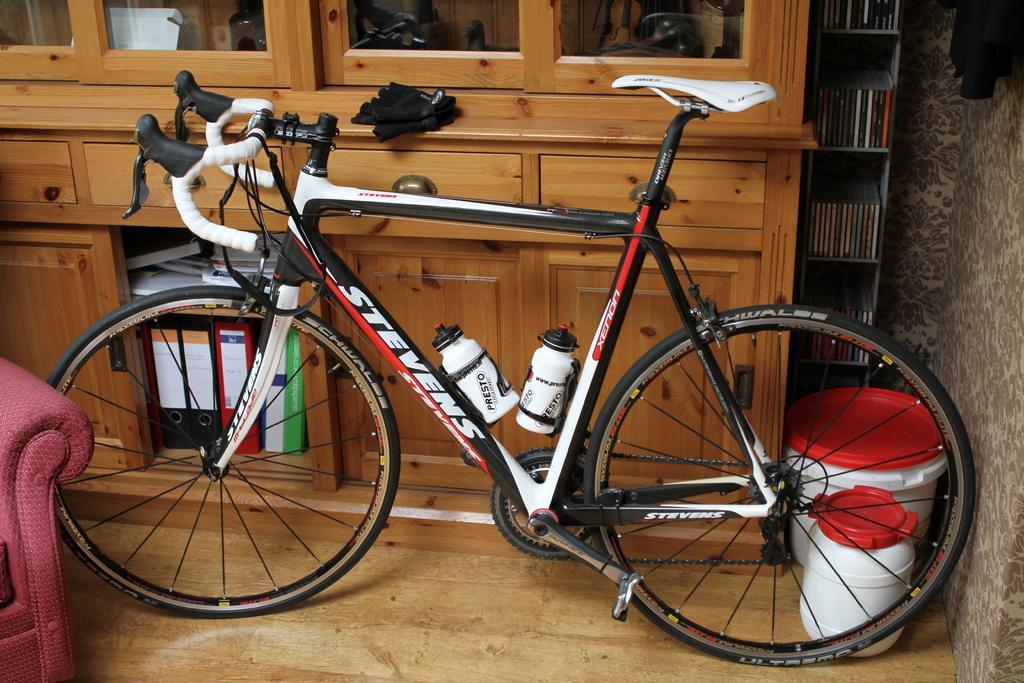How would you summarize this image in a sentence or two? In this image I can see the bicycle which is in black, red and white color. I can see the bottles to the bicycle. To the left there is a maroon color couch. In the background I can see the cupboard and there are some files in it. I can also see the rack with books and the wall. 